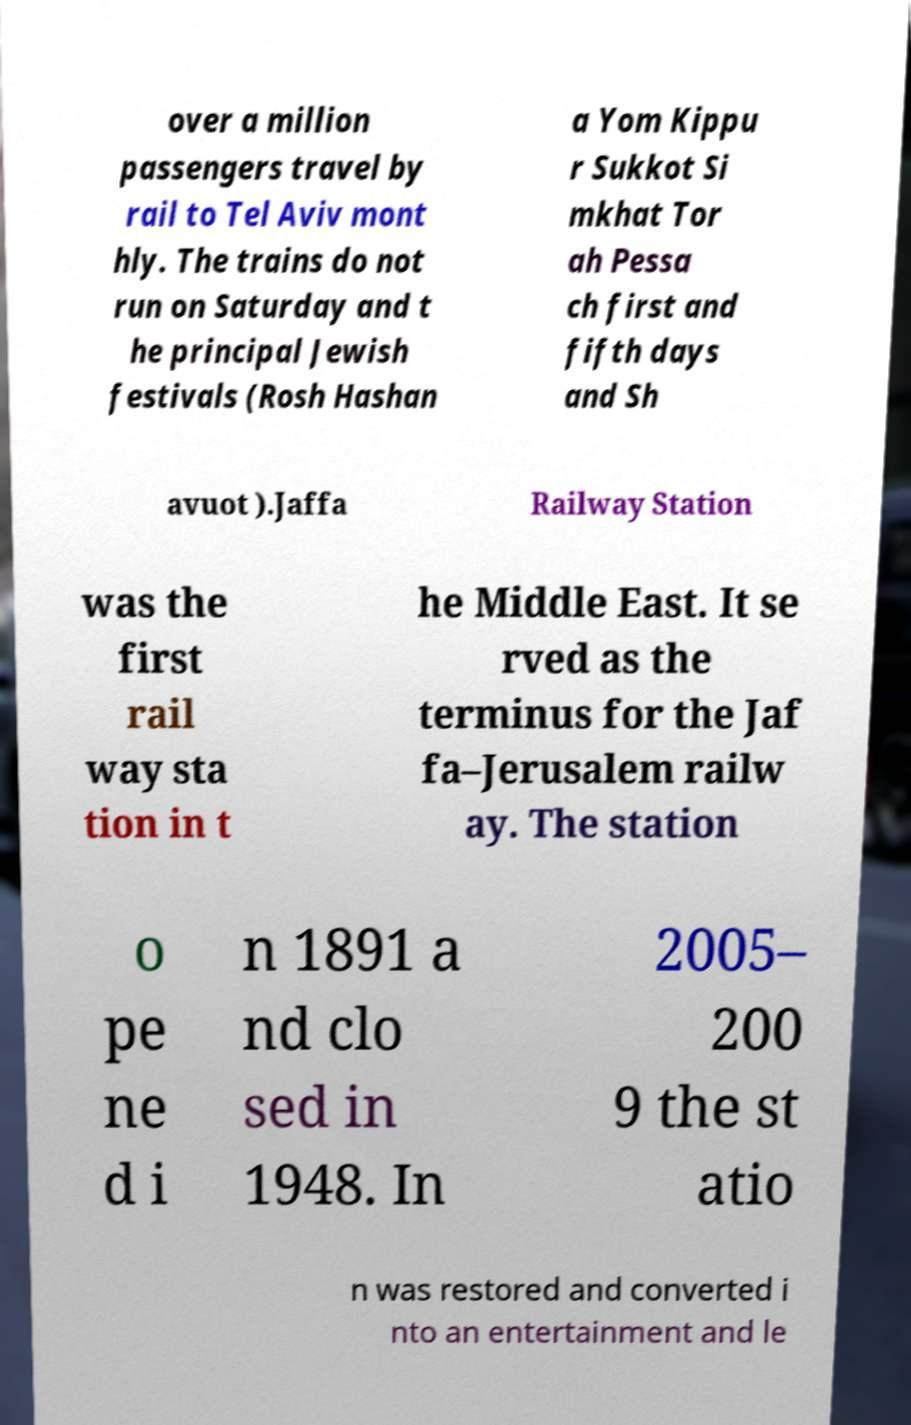Could you assist in decoding the text presented in this image and type it out clearly? over a million passengers travel by rail to Tel Aviv mont hly. The trains do not run on Saturday and t he principal Jewish festivals (Rosh Hashan a Yom Kippu r Sukkot Si mkhat Tor ah Pessa ch first and fifth days and Sh avuot ).Jaffa Railway Station was the first rail way sta tion in t he Middle East. It se rved as the terminus for the Jaf fa–Jerusalem railw ay. The station o pe ne d i n 1891 a nd clo sed in 1948. In 2005– 200 9 the st atio n was restored and converted i nto an entertainment and le 